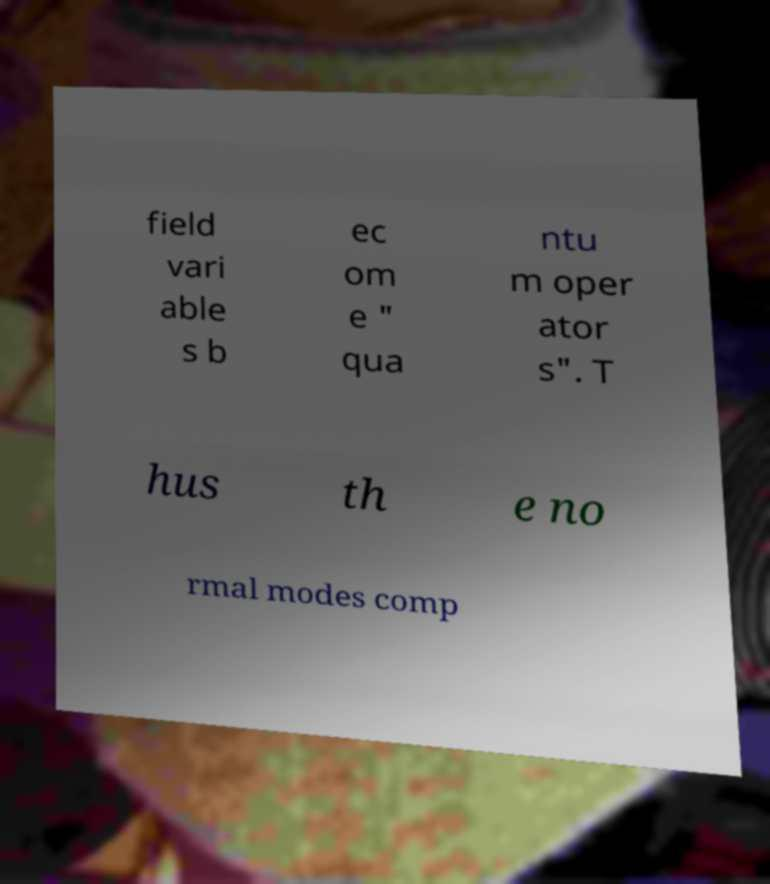Could you assist in decoding the text presented in this image and type it out clearly? field vari able s b ec om e " qua ntu m oper ator s". T hus th e no rmal modes comp 